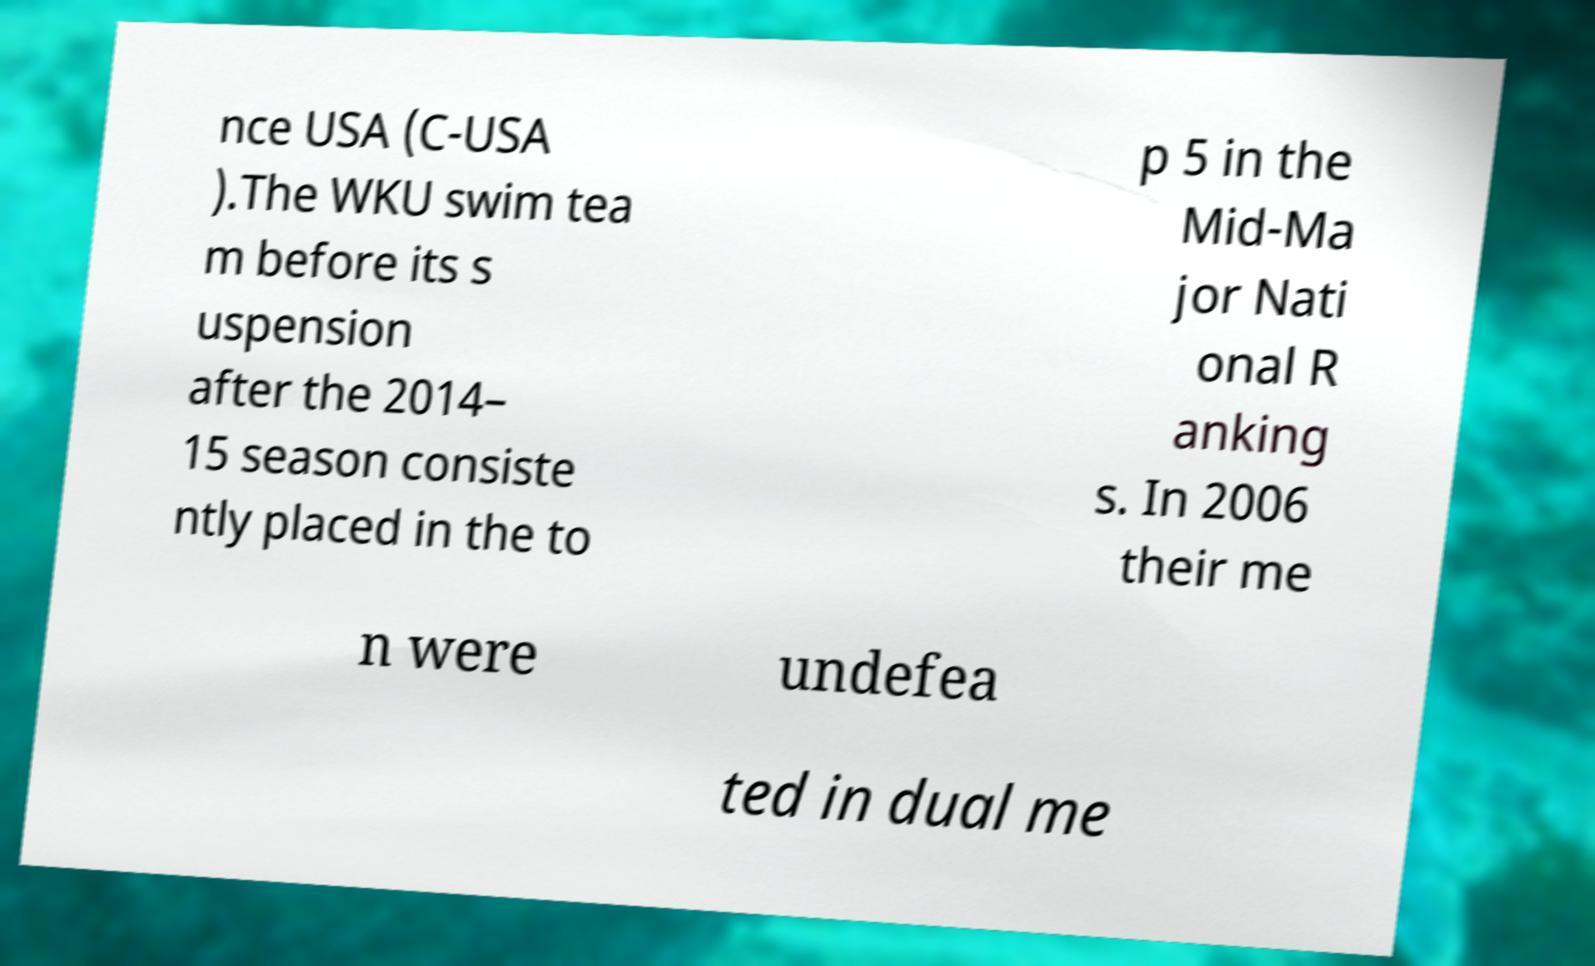Please identify and transcribe the text found in this image. nce USA (C-USA ).The WKU swim tea m before its s uspension after the 2014– 15 season consiste ntly placed in the to p 5 in the Mid-Ma jor Nati onal R anking s. In 2006 their me n were undefea ted in dual me 